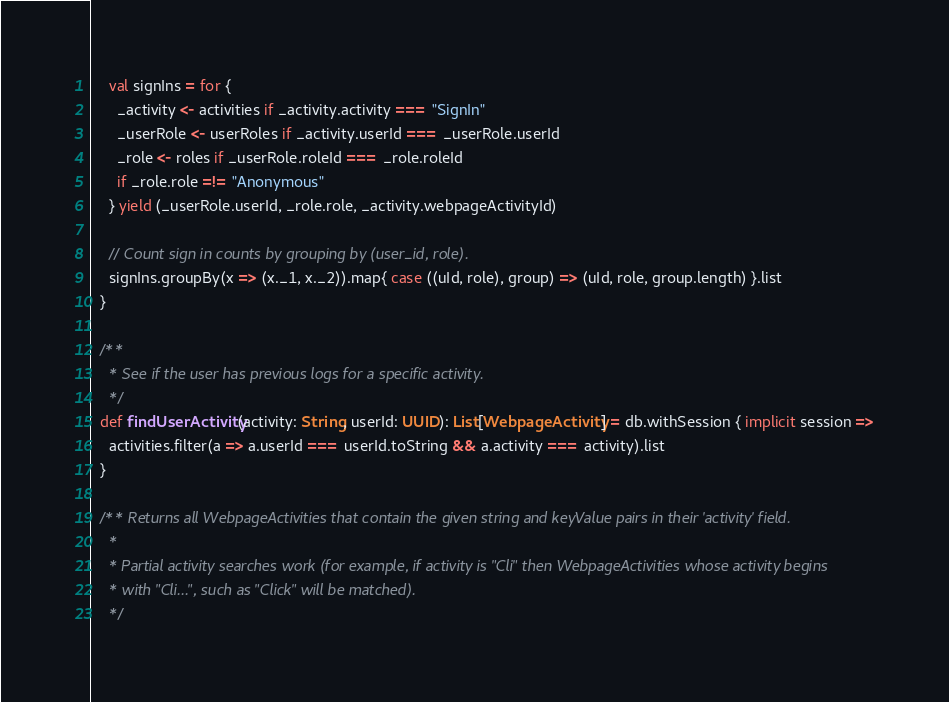Convert code to text. <code><loc_0><loc_0><loc_500><loc_500><_Scala_>    val signIns = for {
      _activity <- activities if _activity.activity === "SignIn"
      _userRole <- userRoles if _activity.userId === _userRole.userId
      _role <- roles if _userRole.roleId === _role.roleId
      if _role.role =!= "Anonymous"
    } yield (_userRole.userId, _role.role, _activity.webpageActivityId)

    // Count sign in counts by grouping by (user_id, role).
    signIns.groupBy(x => (x._1, x._2)).map{ case ((uId, role), group) => (uId, role, group.length) }.list
  }

  /**
    * See if the user has previous logs for a specific activity.
    */
  def findUserActivity(activity: String, userId: UUID): List[WebpageActivity] = db.withSession { implicit session =>
    activities.filter(a => a.userId === userId.toString && a.activity === activity).list
  }

  /** Returns all WebpageActivities that contain the given string and keyValue pairs in their 'activity' field.
    *
    * Partial activity searches work (for example, if activity is "Cli" then WebpageActivities whose activity begins
    * with "Cli...", such as "Click" will be matched).
    */</code> 